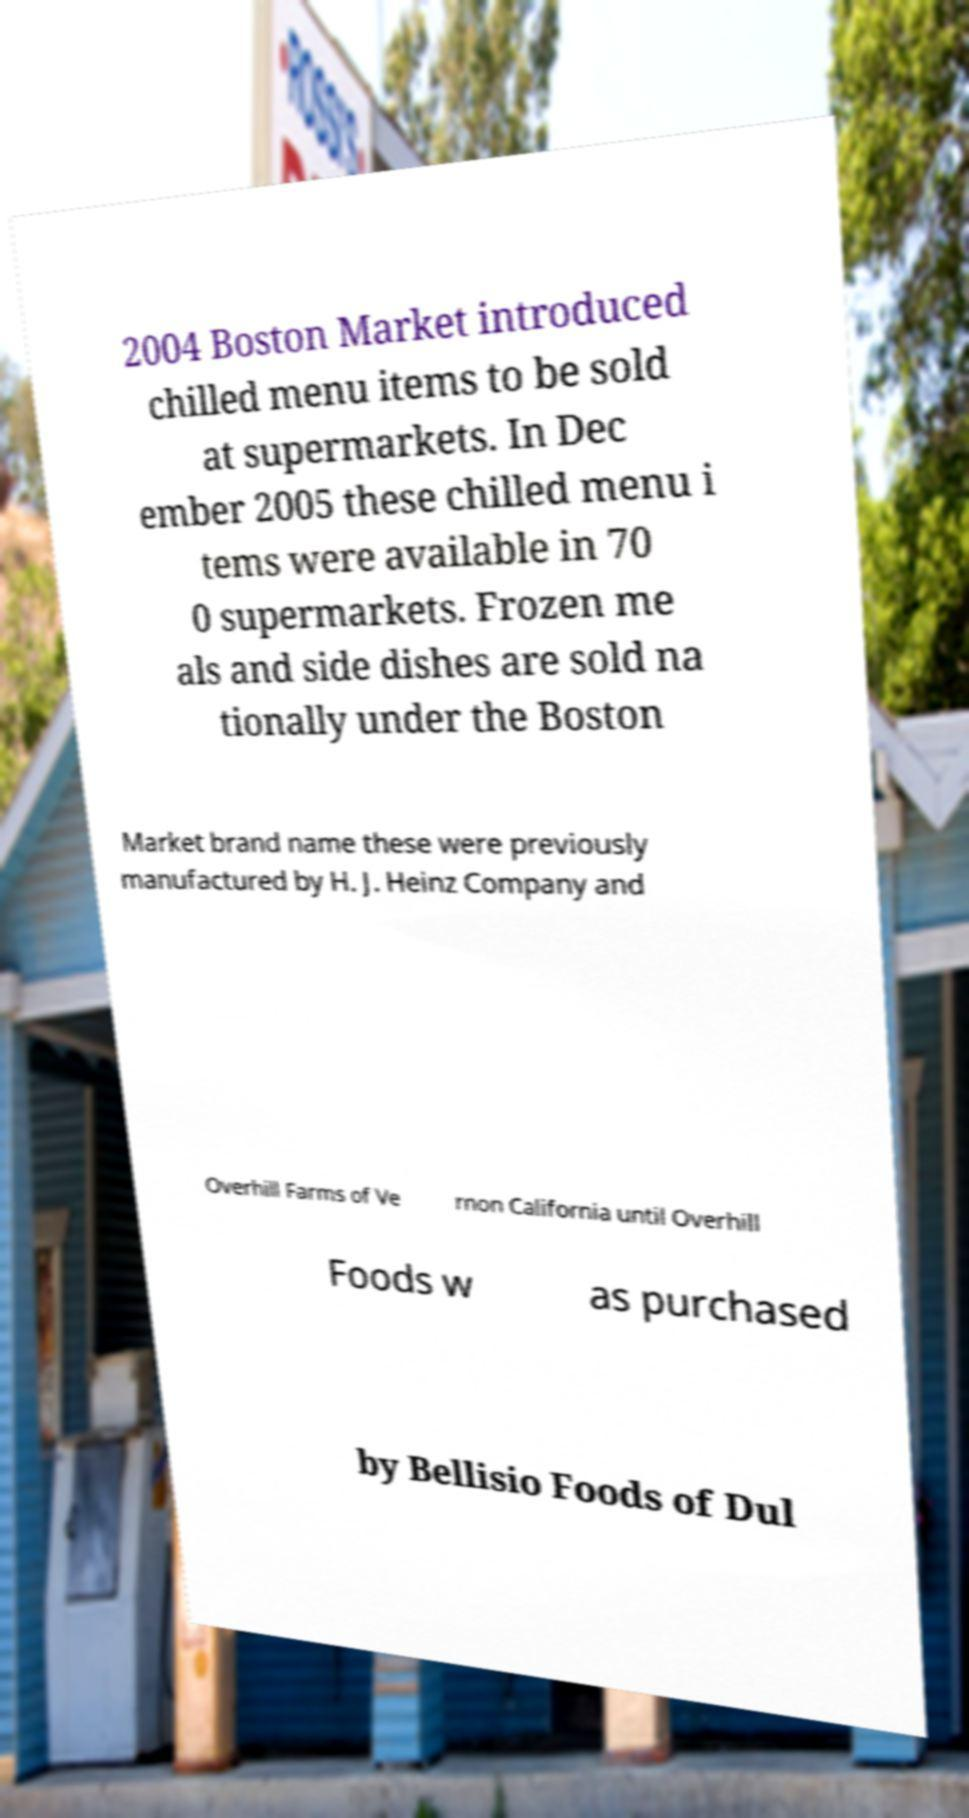Could you extract and type out the text from this image? 2004 Boston Market introduced chilled menu items to be sold at supermarkets. In Dec ember 2005 these chilled menu i tems were available in 70 0 supermarkets. Frozen me als and side dishes are sold na tionally under the Boston Market brand name these were previously manufactured by H. J. Heinz Company and Overhill Farms of Ve rnon California until Overhill Foods w as purchased by Bellisio Foods of Dul 